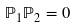<formula> <loc_0><loc_0><loc_500><loc_500>\mathbb { P } _ { 1 } \mathbb { P } _ { 2 } = 0</formula> 